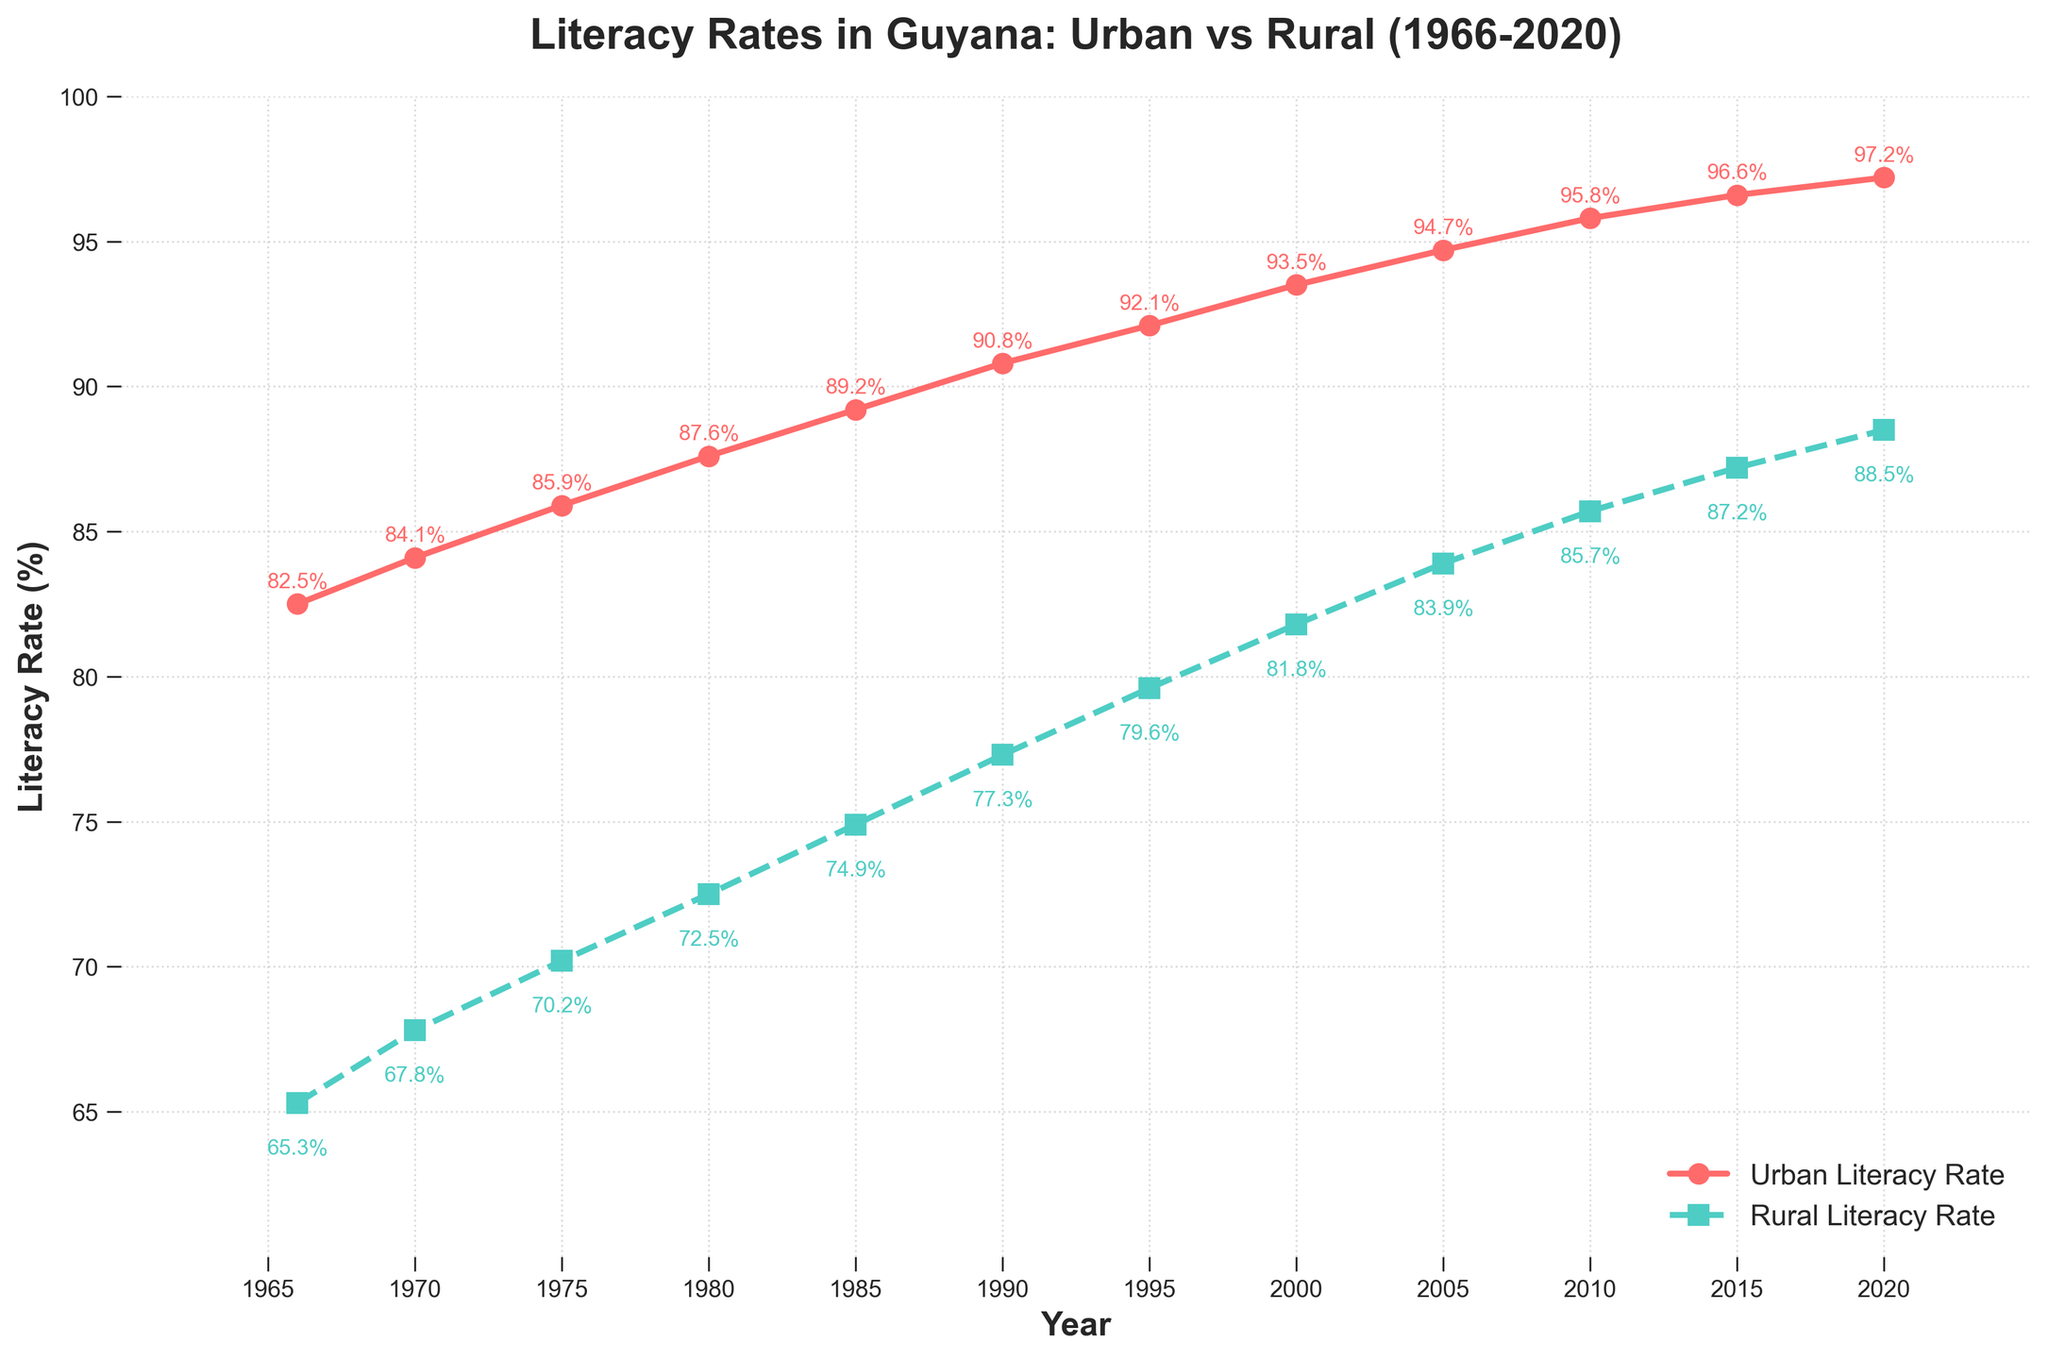What were the literacy rates for both urban and rural areas in the year 1970? On the chart, locate the data points corresponding to the year 1970 for both urban and rural areas. The urban literacy rate is indicated at just above 84%, and the rural literacy rate is slightly below 68%.
Answer: 84.1% (urban), 67.8% (rural) How much did the rural literacy rate increase from 1966 to 1980? Find the rural literacy rates for the years 1966 and 1980, which are approximately 65.3% and 72.5% respectively. Subtract the earlier value from the later value: 72.5% - 65.3% = 7.2%.
Answer: 7.2% Did either urban or rural areas achieve a literacy rate of over 90% by 1990? Check the data points for 1990. The urban literacy rate is over 90% at around 90.8%, while the rural literacy rate is 77.3%.
Answer: Yes, urban areas By how much did the gap between urban and rural literacy rates decrease from 1966 to 2020? Calculate the differences for 1966 (82.5% - 65.3% = 17.2%) and 2020 (97.2% - 88.5% = 8.7%). Subtract the 2020 difference from the 1966 difference: 17.2% - 8.7% = 8.5%.
Answer: 8.5% What is the trend in literacy rates for rural areas from 2000 to 2020? Observe the data points for rural literacy rates from 2000 to 2020, starting at 81.8% and ending at 88.5%. Note that there is a consistent increasing trend throughout these years.
Answer: Increasing In what year did the urban literacy rate first exceed 95%? Look at the urban literacy data points and identify when it first goes beyond 95%. This occurs around the year 2010 where it reaches 95.8%.
Answer: 2010 How do the literacy rates for urban and rural areas compare in 2015? Observe the data points for 2015. The urban literacy rate is approximately 96.6%, and the rural literacy rate is around 87.2%. Urban literacy rate is higher.
Answer: Urban is higher What is the difference between urban and rural literacy rates in 2000? Find the data points for the year 2000. The urban literacy rate is 93.5% and the rural literacy rate is 81.8%. Subtract rural from urban: 93.5% - 81.8% = 11.7%.
Answer: 11.7% What are the colors used to indicate urban and rural literacy rates on the chart? Identify the colors used for plotting the data. Urban literacy rates are indicated with red, and rural literacy rates with green.
Answer: Red (urban), Green (rural) What is the average rural literacy rate over the entire period? Sum all rural literacy rates over the period (65.3 + 67.8 + 70.2 + 72.5 + 74.9 + 77.3 + 79.6 + 81.8 + 83.9 + 85.7 + 87.2 + 88.5 = 935.7) and divide by the number of years (12): 935.7 / 12 ≈ 77.98%.
Answer: ~77.98% 